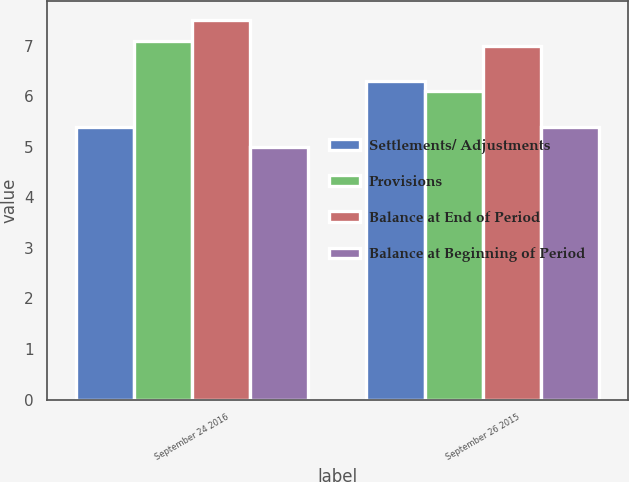<chart> <loc_0><loc_0><loc_500><loc_500><stacked_bar_chart><ecel><fcel>September 24 2016<fcel>September 26 2015<nl><fcel>Settlements/ Adjustments<fcel>5.4<fcel>6.3<nl><fcel>Provisions<fcel>7.1<fcel>6.1<nl><fcel>Balance at End of Period<fcel>7.5<fcel>7<nl><fcel>Balance at Beginning of Period<fcel>5<fcel>5.4<nl></chart> 